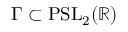<formula> <loc_0><loc_0><loc_500><loc_500>\Gamma \subset P S L _ { 2 } ( \mathbb { R } )</formula> 